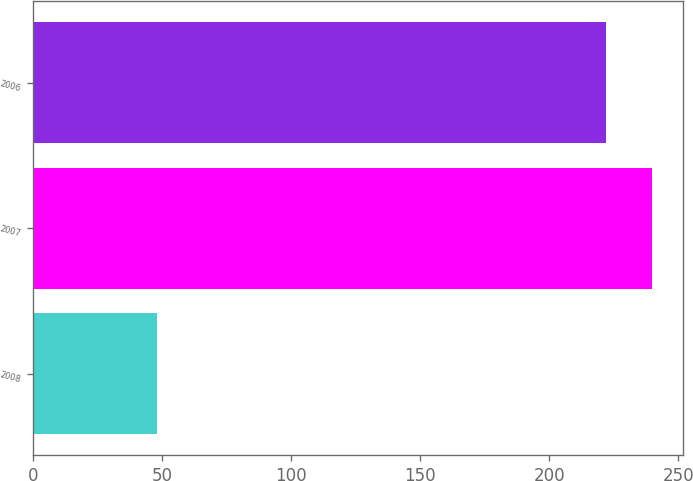<chart> <loc_0><loc_0><loc_500><loc_500><bar_chart><fcel>2008<fcel>2007<fcel>2006<nl><fcel>48<fcel>240<fcel>222<nl></chart> 